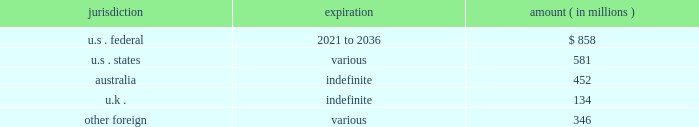News corporation notes to the consolidated financial statements as of june 30 , 2016 , the company had income tax net operating loss carryforwards ( nols ) ( gross , net of uncertain tax benefits ) , in various jurisdictions as follows : jurisdiction expiration amount ( in millions ) .
Utilization of the nols is dependent on generating sufficient taxable income from our operations in each of the respective jurisdictions to which the nols relate , while taking into account limitations and/or restrictions on our ability to use them .
Certain of our u.s .
Federal nols were acquired as part of the acquisitions of move and harlequin and are subject to limitations as promulgated under section 382 of the code .
Section 382 of the code limits the amount of acquired nols that we can use on an annual basis to offset future u.s .
Consolidated taxable income .
The nols are also subject to review by relevant tax authorities in the jurisdictions to which they relate .
The company recorded a deferred tax asset of $ 580 million and $ 540 million ( net of approximately $ 53 million and $ 95 million , respectively , of unrecognized tax benefits ) associated with its nols as of june 30 , 2016 and 2015 , respectively .
Significant judgment is applied in assessing our ability to realize our nols and other tax assets .
Management assesses the available positive and negative evidence to estimate if sufficient future taxable income will be generated to utilize existing deferred tax assets within the applicable expiration period .
On the basis of this evaluation , valuation allowances of $ 97 million and $ 304 million have been established to reduce the deferred tax asset associated with the company 2019s nols to an amount that will more likely than not be realized as of june 30 , 2016 and 2015 , respectively .
The amount of the nol deferred tax asset considered realizable , however , could be adjusted if estimates of future taxable income during the carryforward period are reduced or if objective negative evidence in the form of cumulative losses occurs .
As of june 30 , 2016 , the company had approximately $ 1.6 billion and $ 1.7 billion of capital loss carryforwards in australia and the u.k. , respectively , which may be carried forward indefinitely and which are subject to tax authority review .
Realization of our capital losses is dependent on generating capital gain taxable income and satisfying certain continuity of business requirements .
The company recorded a deferred tax asset of $ 803 million and $ 892 million as of june 30 , 2016 and 2015 , respectively for these capital loss carryforwards , however , it is more likely than not that the company will not generate capital gain income in the normal course of business in these jurisdictions .
Accordingly , valuation allowances of $ 803 million and $ 892 million have been established to reduce the capital loss carryforward deferred tax asset to an amount that will more likely than not be realized as of june 30 , 2016 and 2015 , respectively .
As of june 30 , 2016 , the company had approximately $ 26 million of u.s .
Federal tax credit carryforward which includes $ 22 million of foreign tax credits and $ 4 million of research & development credits which begin to expire in 2025 and 2036 , respectively .
As of june 30 , 2016 , the company had approximately $ 5 million of non-u.s .
Tax credit carryforwards which expire in various amounts beginning in 2025 and $ 8 million of state tax credit carryforwards ( net of u.s .
Federal benefit ) , of which the balance can be carried forward indefinitely .
In accordance with the company 2019s accounting policy , a valuation allowance of $ 5 million has been established to reduce the deferred tax asset associated with the company 2019s non-u.s .
And state credit carryforwards to an amount that will more likely than not be realized as of june 30 , 2016. .
What was the percentage change in the the company recorded a deferred tax asset associated with its nols from 2015 to 2016? 
Rationale: the company recorded deferred tax asset associated with its nols increased by 7.4% from 2015 to 2016
Computations: ((580 - 540) / 540)
Answer: 0.07407. 